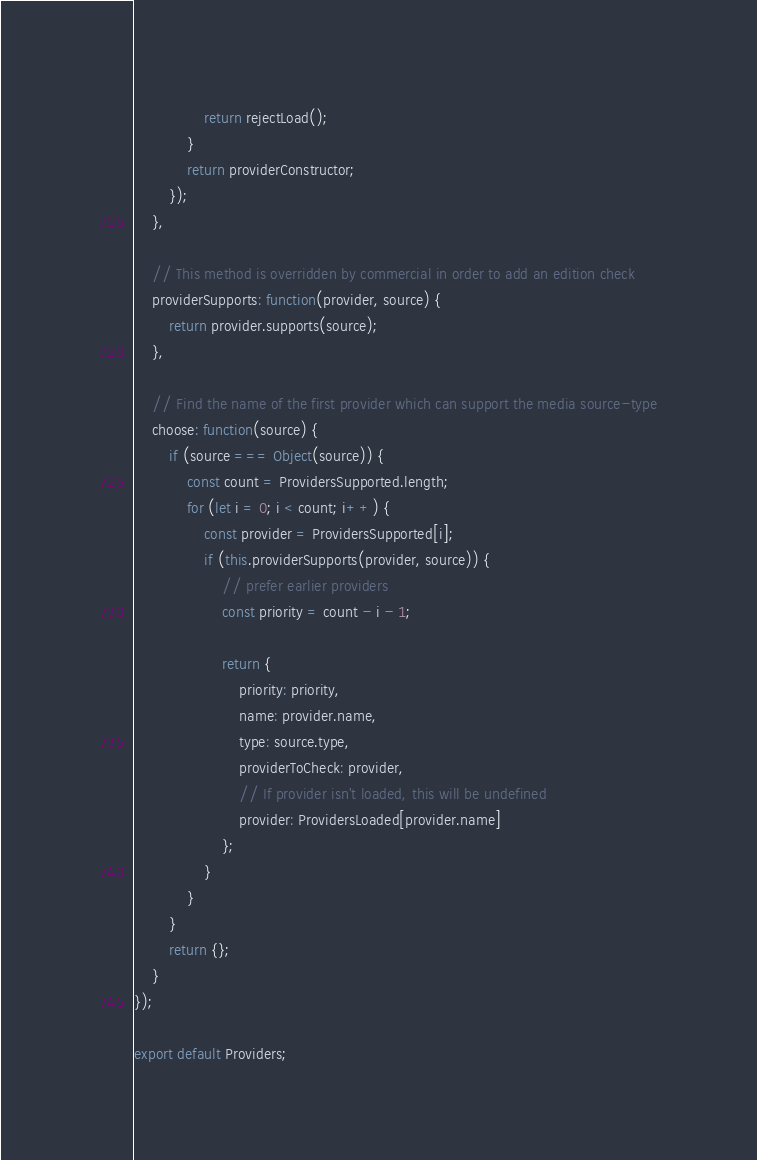<code> <loc_0><loc_0><loc_500><loc_500><_JavaScript_>                return rejectLoad();
            }
            return providerConstructor;
        });
    },

    // This method is overridden by commercial in order to add an edition check
    providerSupports: function(provider, source) {
        return provider.supports(source);
    },

    // Find the name of the first provider which can support the media source-type
    choose: function(source) {
        if (source === Object(source)) {
            const count = ProvidersSupported.length;
            for (let i = 0; i < count; i++) {
                const provider = ProvidersSupported[i];
                if (this.providerSupports(provider, source)) {
                    // prefer earlier providers
                    const priority = count - i - 1;

                    return {
                        priority: priority,
                        name: provider.name,
                        type: source.type,
                        providerToCheck: provider,
                        // If provider isn't loaded, this will be undefined
                        provider: ProvidersLoaded[provider.name]
                    };
                }
            }
        }
        return {};
    }
});

export default Providers;
</code> 